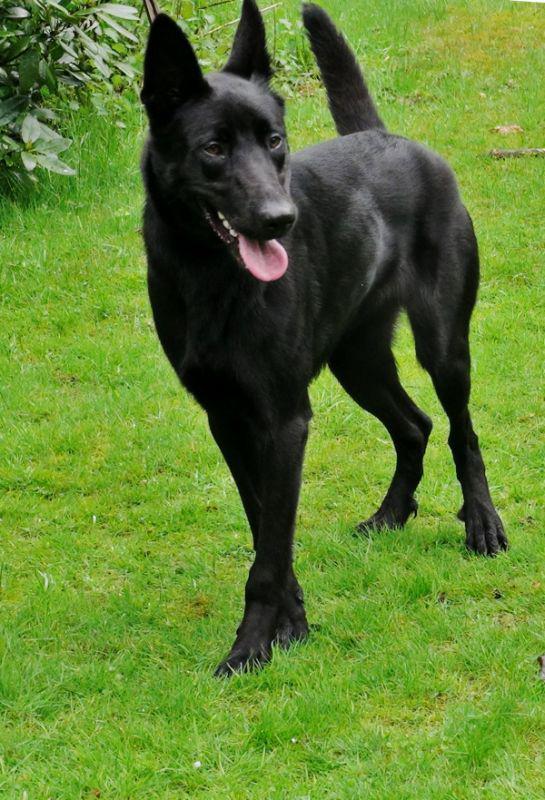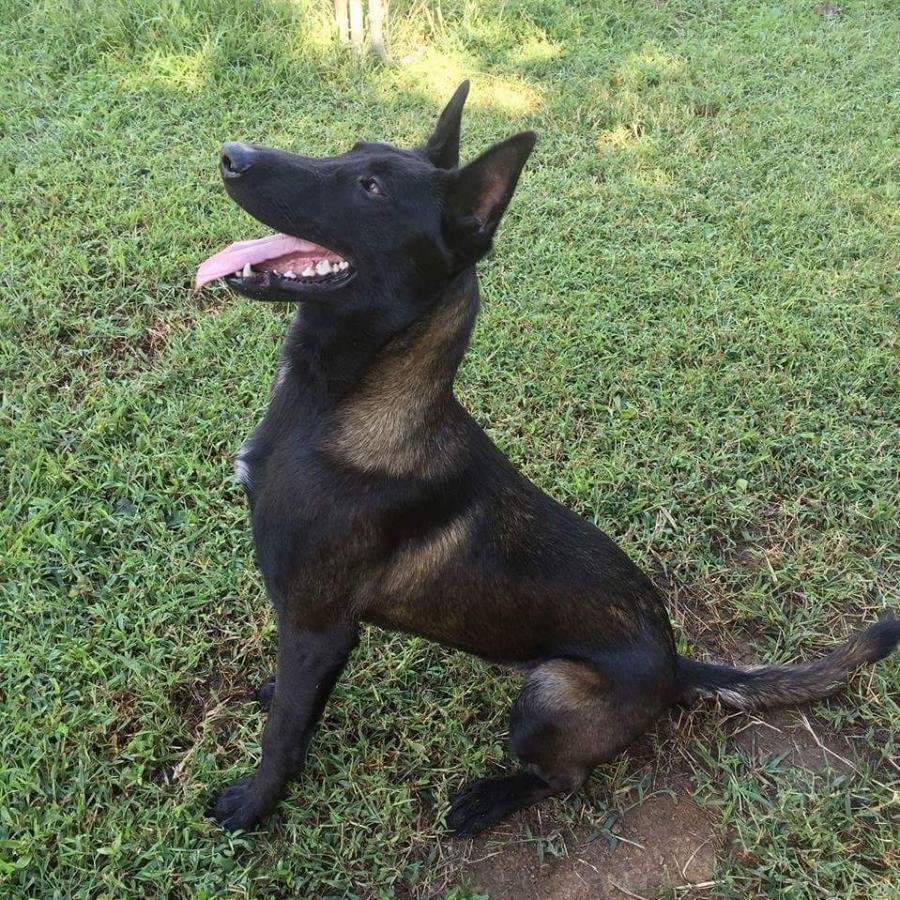The first image is the image on the left, the second image is the image on the right. Evaluate the accuracy of this statement regarding the images: "At least one dog is running toward the camera.". Is it true? Answer yes or no. No. The first image is the image on the left, the second image is the image on the right. For the images displayed, is the sentence "An image shows a dog running toward the camera and facing forward." factually correct? Answer yes or no. No. 